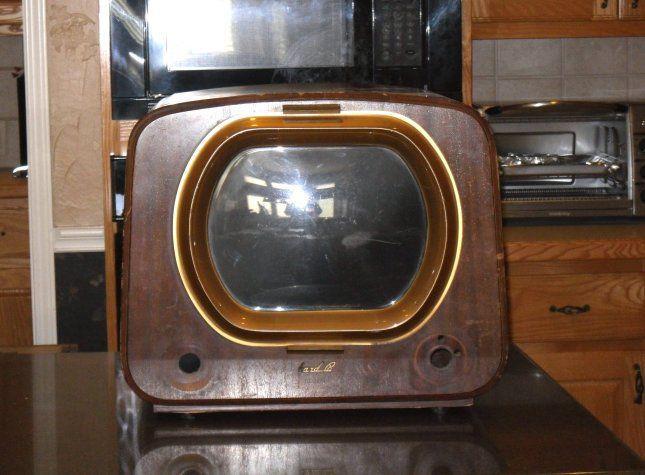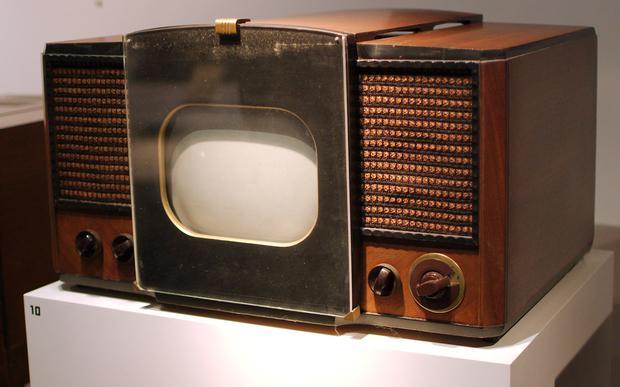The first image is the image on the left, the second image is the image on the right. For the images shown, is this caption "A television is turned on." true? Answer yes or no. No. The first image is the image on the left, the second image is the image on the right. Given the left and right images, does the statement "In at least one image there is a small rectangle tv sitting on a white table." hold true? Answer yes or no. Yes. 